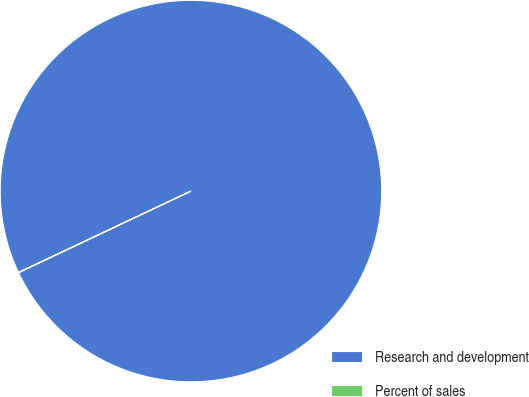Convert chart. <chart><loc_0><loc_0><loc_500><loc_500><pie_chart><fcel>Research and development<fcel>Percent of sales<nl><fcel>99.98%<fcel>0.02%<nl></chart> 